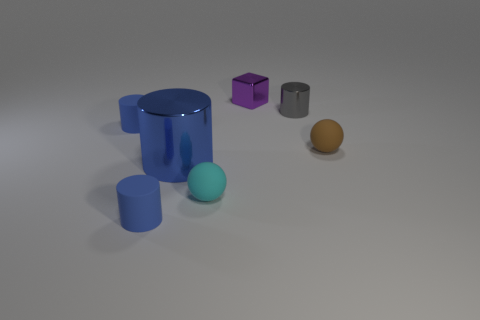How many blue cylinders must be subtracted to get 1 blue cylinders? 2 Subtract all gray cubes. How many blue cylinders are left? 3 Subtract 1 cylinders. How many cylinders are left? 3 Subtract all cyan balls. Subtract all yellow cylinders. How many balls are left? 1 Add 1 small gray objects. How many objects exist? 8 Subtract all cylinders. How many objects are left? 3 Add 7 small cubes. How many small cubes are left? 8 Add 4 cyan shiny cylinders. How many cyan shiny cylinders exist? 4 Subtract 0 red cylinders. How many objects are left? 7 Subtract all green matte cubes. Subtract all gray metallic cylinders. How many objects are left? 6 